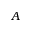<formula> <loc_0><loc_0><loc_500><loc_500>A</formula> 